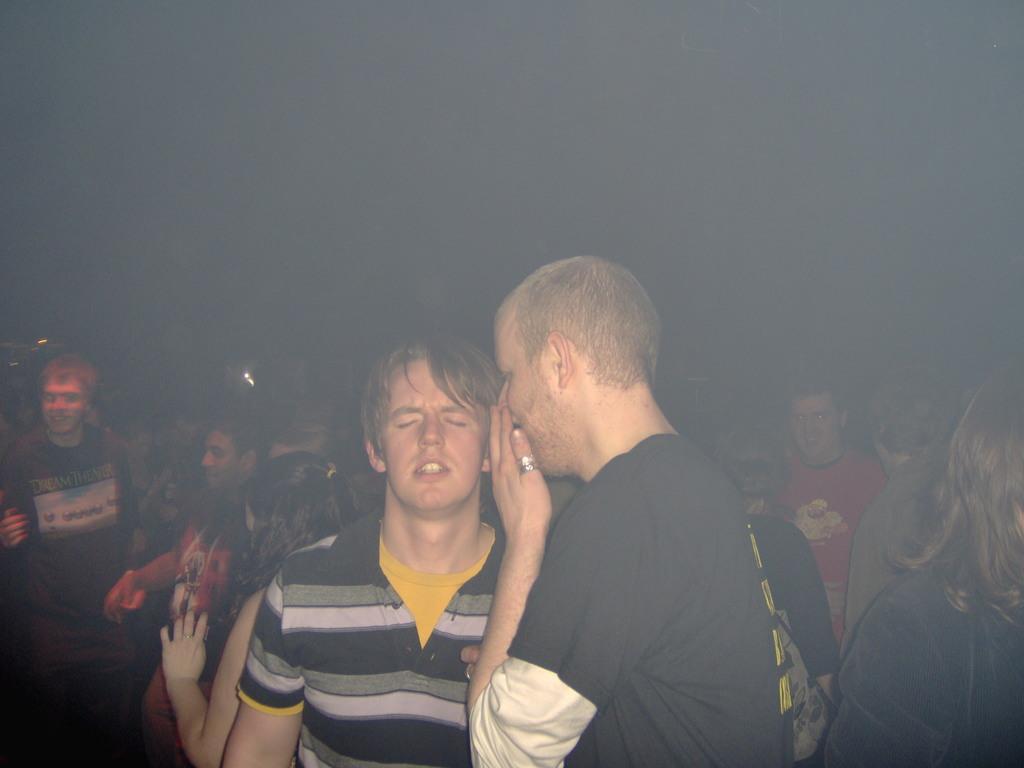Could you give a brief overview of what you see in this image? These two persons are standing. Background we can see people and it is dark. 